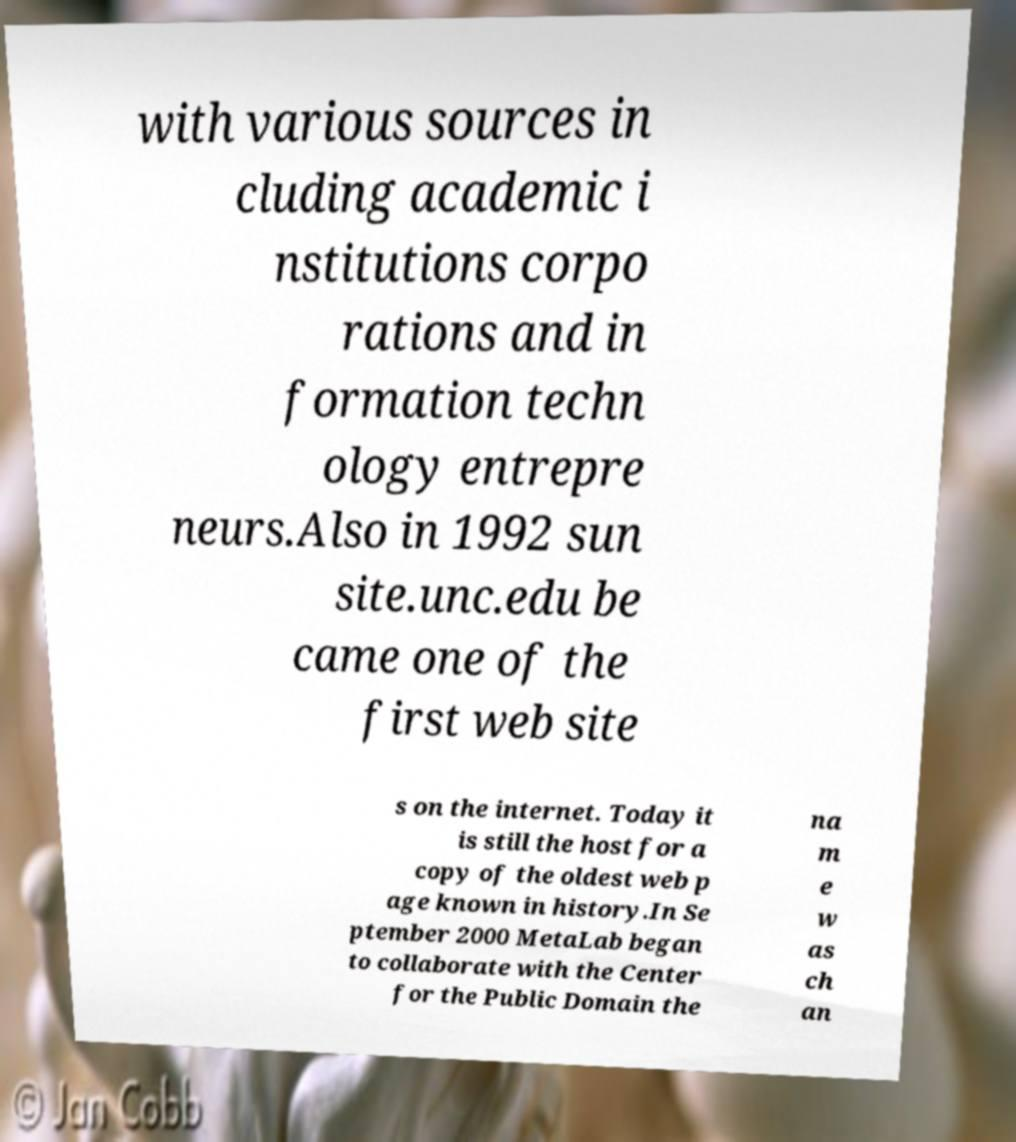Could you assist in decoding the text presented in this image and type it out clearly? with various sources in cluding academic i nstitutions corpo rations and in formation techn ology entrepre neurs.Also in 1992 sun site.unc.edu be came one of the first web site s on the internet. Today it is still the host for a copy of the oldest web p age known in history.In Se ptember 2000 MetaLab began to collaborate with the Center for the Public Domain the na m e w as ch an 